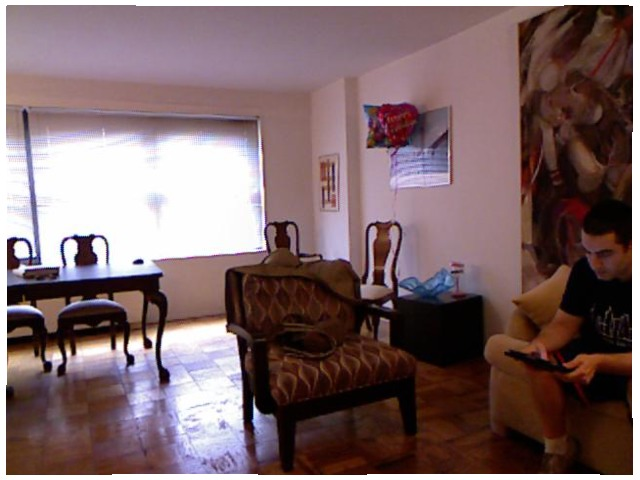<image>
Is there a chair in front of the table? No. The chair is not in front of the table. The spatial positioning shows a different relationship between these objects. Is the man on the sofa? Yes. Looking at the image, I can see the man is positioned on top of the sofa, with the sofa providing support. Where is the man in relation to the chair? Is it on the chair? No. The man is not positioned on the chair. They may be near each other, but the man is not supported by or resting on top of the chair. Where is the balloons in relation to the chair? Is it above the chair? Yes. The balloons is positioned above the chair in the vertical space, higher up in the scene. Is there a chair to the right of the table? No. The chair is not to the right of the table. The horizontal positioning shows a different relationship. 